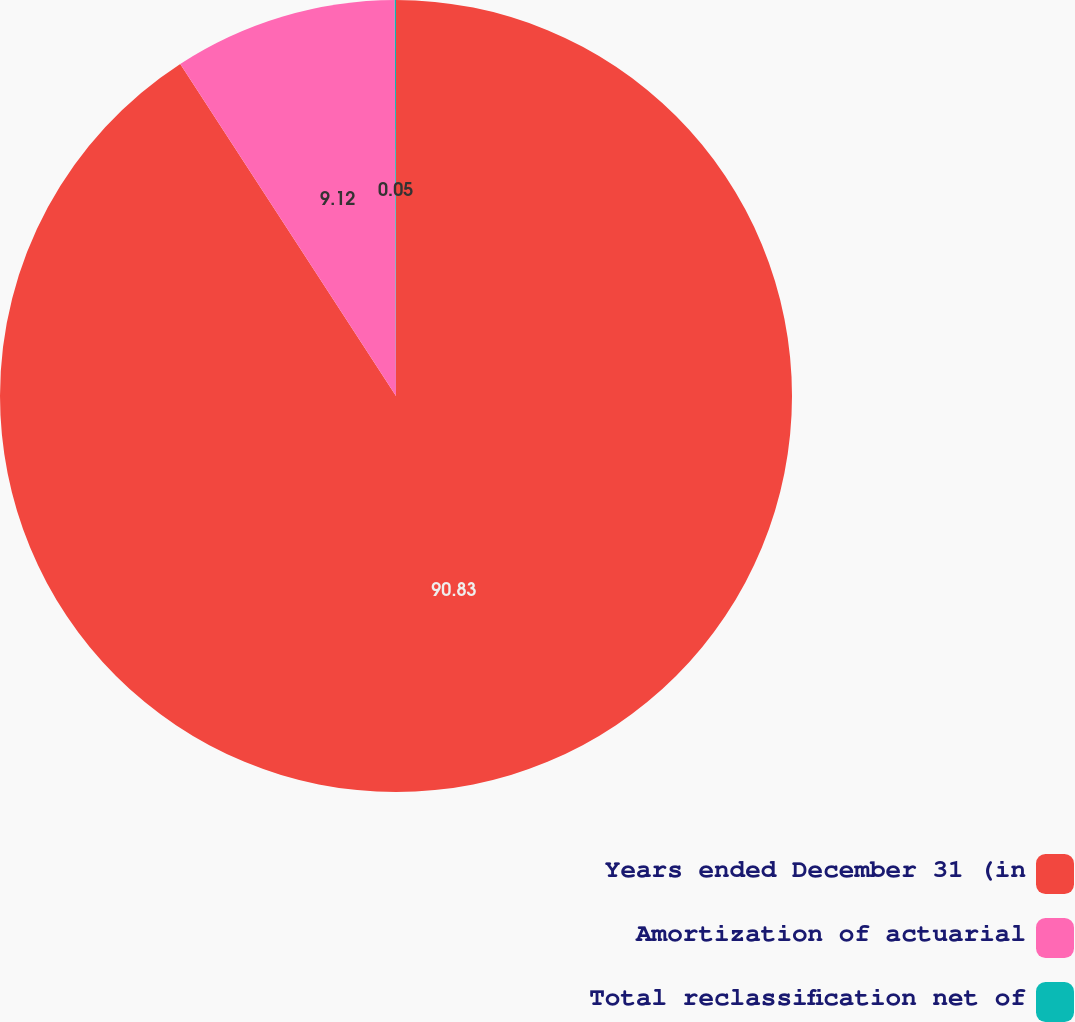Convert chart to OTSL. <chart><loc_0><loc_0><loc_500><loc_500><pie_chart><fcel>Years ended December 31 (in<fcel>Amortization of actuarial<fcel>Total reclassification net of<nl><fcel>90.83%<fcel>9.12%<fcel>0.05%<nl></chart> 